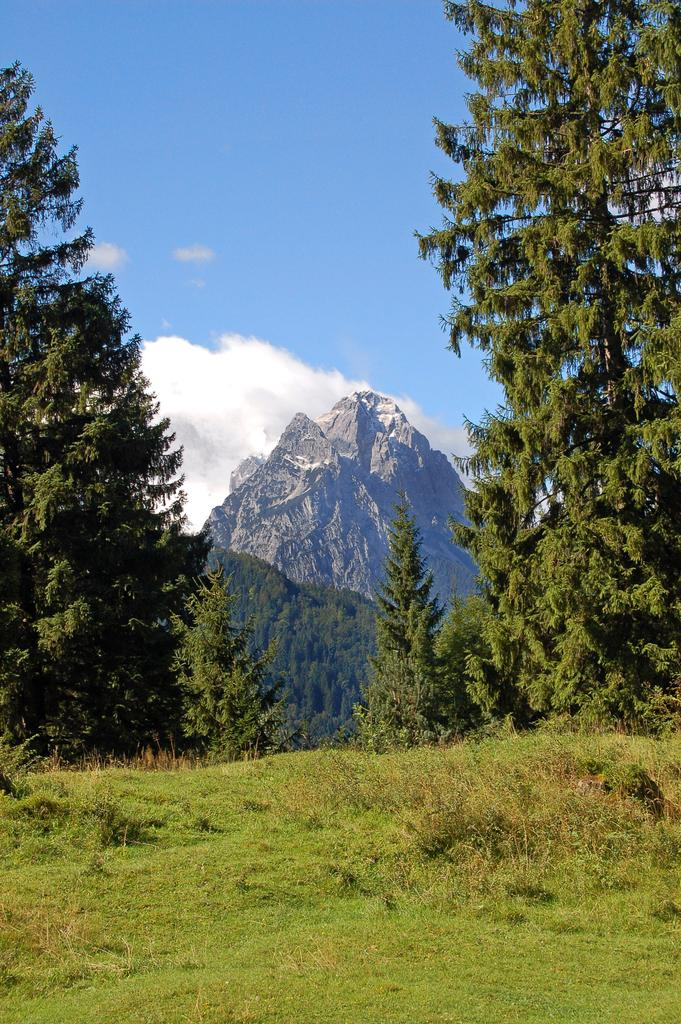What is the main feature in the center of the image? There is a mountain in the center of the image. What type of vegetation can be seen in the image? There are trees in the image. What is present at the bottom of the image? There is grass at the bottom of the image. What color is the underwear of the person standing on the mountain in the image? There is no person or underwear present in the image; it only features a mountain, trees, and grass. 